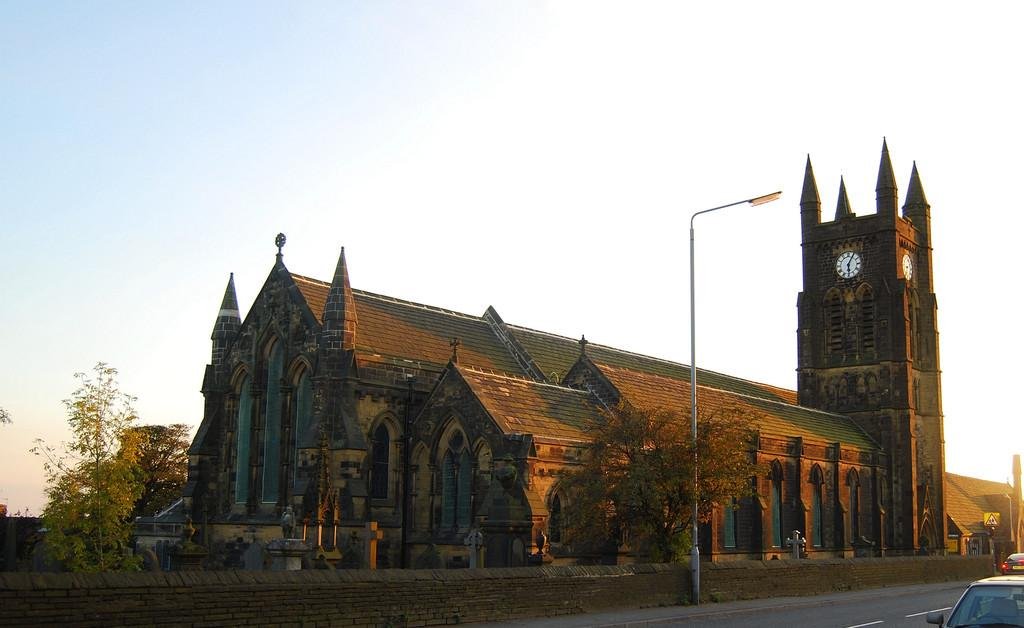What can be seen in the bottom right corner of the image? There are vehicles on the road in the bottom right corner of the image. What is visible in the background of the image? Buildings, windows, trees, a sign board, a pole, street lights, and the sky are visible in the background of the image. What type of patch can be seen on the ocean in the image? There is no ocean present in the image, so there cannot be a patch on it. 